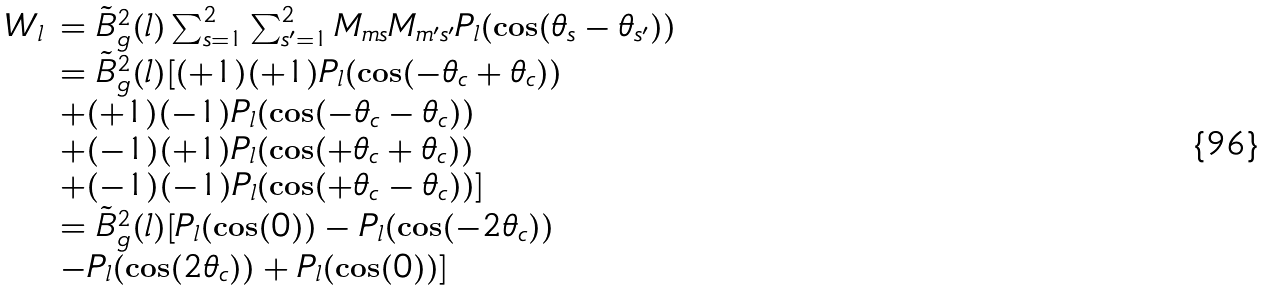Convert formula to latex. <formula><loc_0><loc_0><loc_500><loc_500>\begin{array} { l l } W _ { l } & = \tilde { B } _ { g } ^ { 2 } ( l ) \sum _ { s = 1 } ^ { 2 } \sum _ { s ^ { \prime } = 1 } ^ { 2 } M _ { m s } M _ { m ^ { \prime } s ^ { \prime } } P _ { l } ( \cos ( \theta _ { s } - \theta _ { s ^ { \prime } } ) ) \\ & = \tilde { B } _ { g } ^ { 2 } ( l ) [ ( + 1 ) ( + 1 ) P _ { l } ( \cos ( - \theta _ { c } + \theta _ { c } ) ) \\ & + ( + 1 ) ( - 1 ) P _ { l } ( \cos ( - \theta _ { c } - \theta _ { c } ) ) \\ & + ( - 1 ) ( + 1 ) P _ { l } ( \cos ( + \theta _ { c } + \theta _ { c } ) ) \\ & + ( - 1 ) ( - 1 ) P _ { l } ( \cos ( + \theta _ { c } - \theta _ { c } ) ) ] \\ & = \tilde { B } _ { g } ^ { 2 } ( l ) [ P _ { l } ( \cos ( 0 ) ) - P _ { l } ( \cos ( - 2 \theta _ { c } ) ) \\ & - P _ { l } ( \cos ( 2 \theta _ { c } ) ) + P _ { l } ( \cos ( 0 ) ) ] \end{array}</formula> 